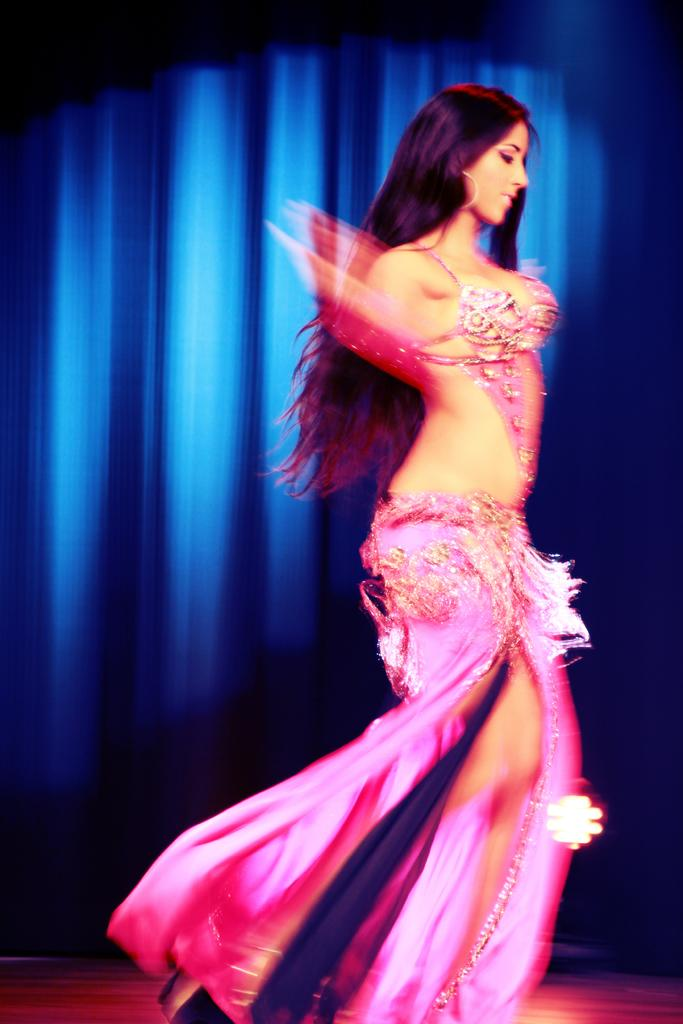Who is the main subject in the image? There is a woman in the image. What is the woman doing in the image? The woman is dancing. What can be seen in the background of the image? There is a curtain in the background of the image. What type of cable is being used by the woman in the image? There is no cable present in the image; the woman is dancing. What type of badge is the woman wearing in the image? There is no badge visible in the image; the woman is dancing and wearing a curtain as a background. 